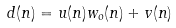<formula> <loc_0><loc_0><loc_500><loc_500>d ( n ) = u ( n ) w _ { o } ( n ) + v ( n )</formula> 